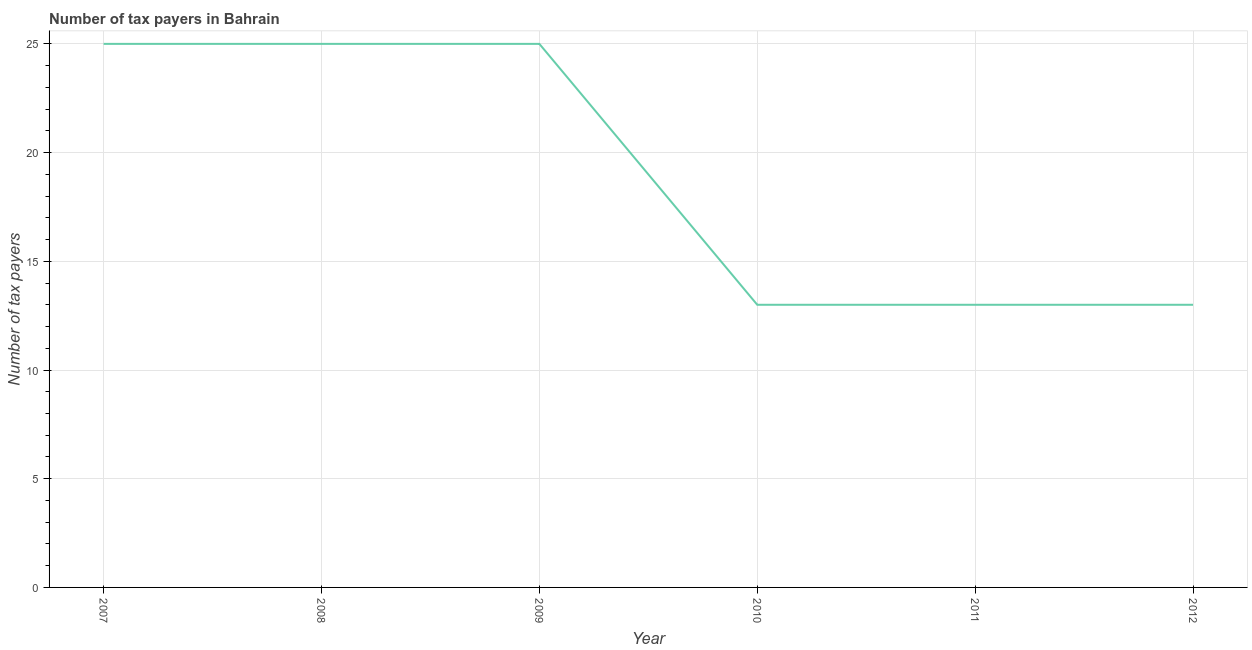What is the number of tax payers in 2010?
Offer a very short reply. 13. Across all years, what is the maximum number of tax payers?
Your answer should be very brief. 25. Across all years, what is the minimum number of tax payers?
Keep it short and to the point. 13. In which year was the number of tax payers maximum?
Your answer should be compact. 2007. In which year was the number of tax payers minimum?
Your answer should be compact. 2010. What is the sum of the number of tax payers?
Your answer should be compact. 114. What is the difference between the number of tax payers in 2007 and 2011?
Your response must be concise. 12. What is the average number of tax payers per year?
Ensure brevity in your answer.  19. What is the median number of tax payers?
Your response must be concise. 19. In how many years, is the number of tax payers greater than 1 ?
Offer a terse response. 6. What is the ratio of the number of tax payers in 2008 to that in 2011?
Keep it short and to the point. 1.92. Is the number of tax payers in 2007 less than that in 2008?
Make the answer very short. No. Is the difference between the number of tax payers in 2008 and 2009 greater than the difference between any two years?
Your response must be concise. No. Is the sum of the number of tax payers in 2008 and 2010 greater than the maximum number of tax payers across all years?
Offer a terse response. Yes. What is the difference between the highest and the lowest number of tax payers?
Offer a very short reply. 12. In how many years, is the number of tax payers greater than the average number of tax payers taken over all years?
Offer a very short reply. 3. How many lines are there?
Your answer should be very brief. 1. What is the difference between two consecutive major ticks on the Y-axis?
Your response must be concise. 5. Does the graph contain any zero values?
Make the answer very short. No. What is the title of the graph?
Provide a short and direct response. Number of tax payers in Bahrain. What is the label or title of the Y-axis?
Your answer should be very brief. Number of tax payers. What is the Number of tax payers in 2010?
Your answer should be very brief. 13. What is the difference between the Number of tax payers in 2007 and 2008?
Your answer should be compact. 0. What is the difference between the Number of tax payers in 2007 and 2009?
Keep it short and to the point. 0. What is the difference between the Number of tax payers in 2007 and 2010?
Offer a terse response. 12. What is the difference between the Number of tax payers in 2007 and 2012?
Make the answer very short. 12. What is the difference between the Number of tax payers in 2009 and 2012?
Offer a very short reply. 12. What is the ratio of the Number of tax payers in 2007 to that in 2008?
Your answer should be very brief. 1. What is the ratio of the Number of tax payers in 2007 to that in 2010?
Ensure brevity in your answer.  1.92. What is the ratio of the Number of tax payers in 2007 to that in 2011?
Your answer should be compact. 1.92. What is the ratio of the Number of tax payers in 2007 to that in 2012?
Ensure brevity in your answer.  1.92. What is the ratio of the Number of tax payers in 2008 to that in 2010?
Offer a very short reply. 1.92. What is the ratio of the Number of tax payers in 2008 to that in 2011?
Your response must be concise. 1.92. What is the ratio of the Number of tax payers in 2008 to that in 2012?
Offer a very short reply. 1.92. What is the ratio of the Number of tax payers in 2009 to that in 2010?
Offer a terse response. 1.92. What is the ratio of the Number of tax payers in 2009 to that in 2011?
Ensure brevity in your answer.  1.92. What is the ratio of the Number of tax payers in 2009 to that in 2012?
Ensure brevity in your answer.  1.92. What is the ratio of the Number of tax payers in 2011 to that in 2012?
Give a very brief answer. 1. 